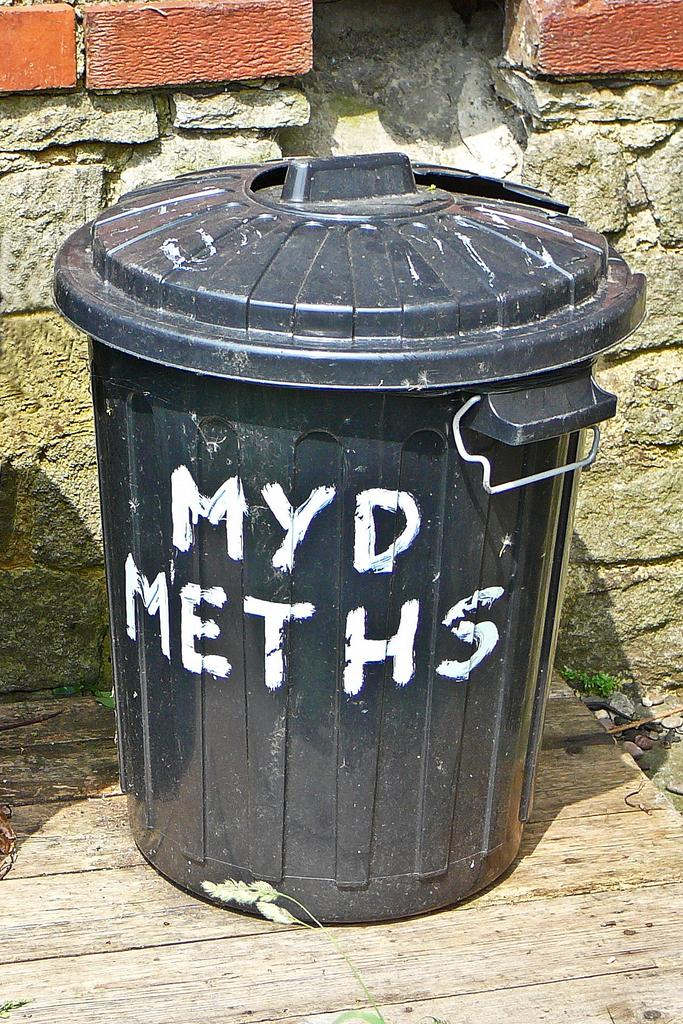<image>
Write a terse but informative summary of the picture. A black trashcan sits on wood boards ant it says MYD Meths on it. 